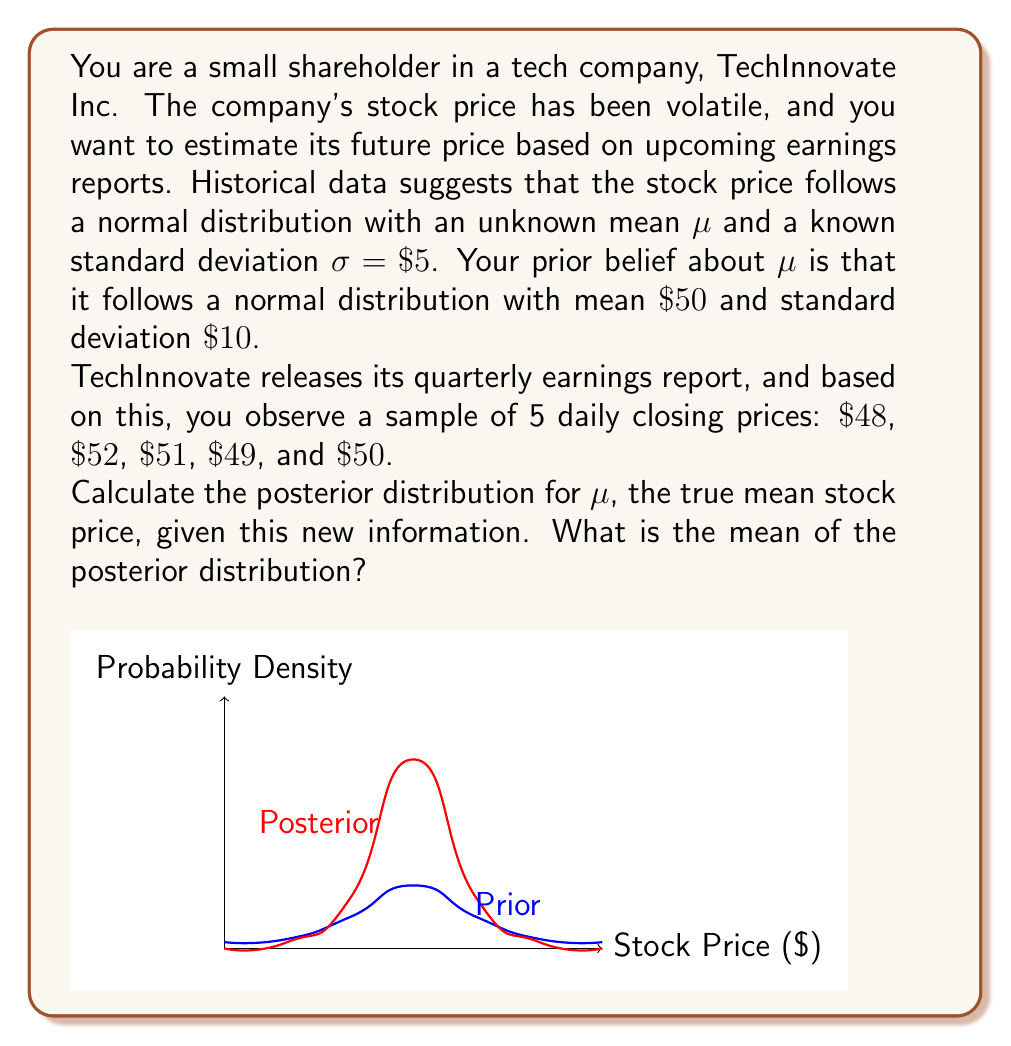Provide a solution to this math problem. Let's approach this step-by-step using Bayesian inference:

1) We have a normal prior for μ: $\mu \sim N(50, 10^2)$

2) The likelihood function is based on the sample data, which follows $N(\mu, 5^2)$

3) For n=5 observations, the sample mean is:
   $$\bar{x} = \frac{48 + 52 + 51 + 49 + 50}{5} = 50$$

4) The posterior distribution for μ will also be normal. We need to calculate its parameters.

5) For conjugate normal priors, the posterior mean is a weighted average of the prior mean and the sample mean:

   $$\mu_{posterior} = \frac{\frac{\mu_{prior}}{\sigma_{prior}^2} + \frac{n\bar{x}}{\sigma^2}}{\frac{1}{\sigma_{prior}^2} + \frac{n}{\sigma^2}}$$

6) The posterior precision (inverse of variance) is the sum of the prior and data precisions:

   $$\frac{1}{\sigma_{posterior}^2} = \frac{1}{\sigma_{prior}^2} + \frac{n}{\sigma^2}$$

7) Let's calculate:
   $$\frac{1}{\sigma_{posterior}^2} = \frac{1}{10^2} + \frac{5}{5^2} = 0.01 + 0.2 = 0.21$$
   $$\sigma_{posterior}^2 = \frac{1}{0.21} = 4.7619$$
   $$\sigma_{posterior} = \sqrt{4.7619} = 2.1826$$

8) Now for the posterior mean:
   $$\mu_{posterior} = \frac{\frac{50}{10^2} + \frac{5(50)}{5^2}}{0.21} = \frac{0.5 + 10}{0.21} = 50$$

Therefore, the posterior distribution for μ is $N(50, 2.1826^2)$.
Answer: $\mu_{posterior} = 50$ 